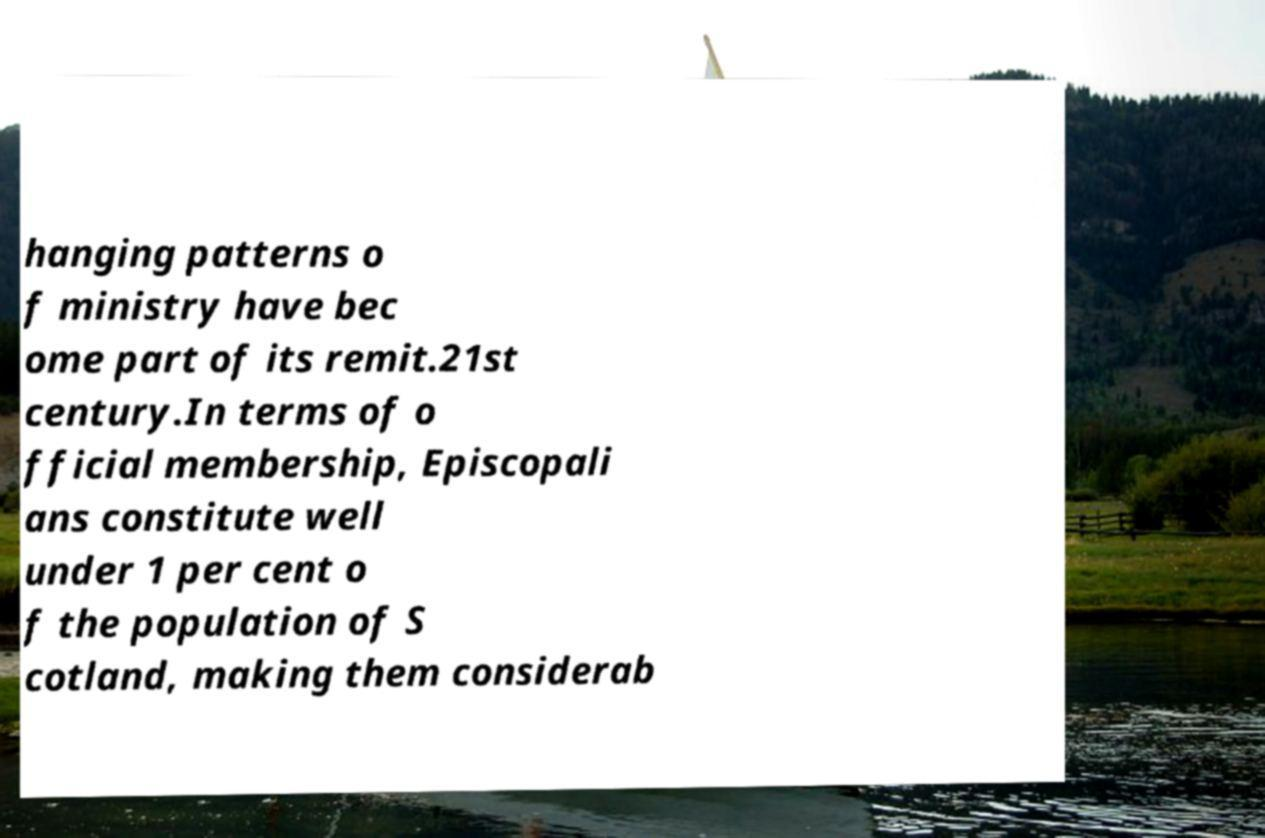Can you accurately transcribe the text from the provided image for me? hanging patterns o f ministry have bec ome part of its remit.21st century.In terms of o fficial membership, Episcopali ans constitute well under 1 per cent o f the population of S cotland, making them considerab 